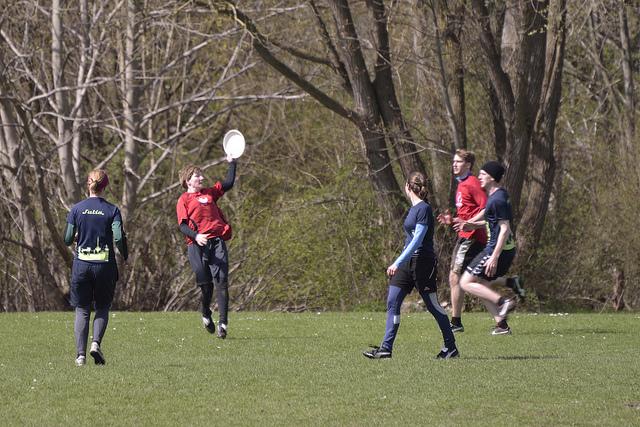How many people are there?
Concise answer only. 5. What game are they playing?
Short answer required. Frisbee. What are they playing?
Short answer required. Frisbee. How many people are on the blue team?
Concise answer only. 3. How many people are wearing red?
Quick response, please. 2. What are they riding?
Write a very short answer. Nothing. 